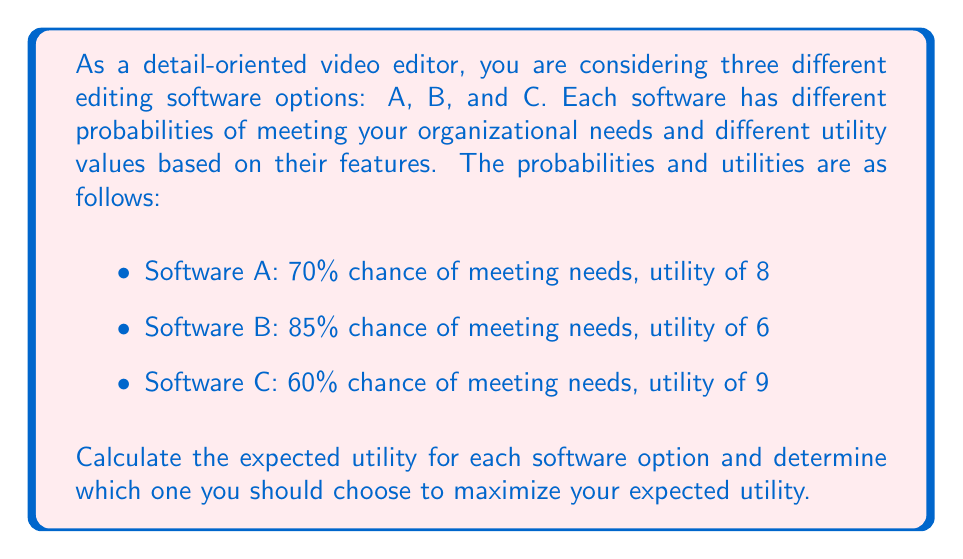Solve this math problem. To solve this problem, we need to calculate the expected utility for each software option using the formula:

$$ E(U) = P(S) \times U(S) + P(F) \times U(F) $$

Where:
$E(U)$ is the expected utility
$P(S)$ is the probability of success (meeting needs)
$U(S)$ is the utility if successful
$P(F)$ is the probability of failure (not meeting needs)
$U(F)$ is the utility if failed

We assume that the utility of failure is 0 for all options.

For Software A:
$$ E(U_A) = 0.70 \times 8 + 0.30 \times 0 = 5.60 $$

For Software B:
$$ E(U_B) = 0.85 \times 6 + 0.15 \times 0 = 5.10 $$

For Software C:
$$ E(U_C) = 0.60 \times 9 + 0.40 \times 0 = 5.40 $$

Comparing the expected utilities:
$$ E(U_A) = 5.60 > E(U_C) = 5.40 > E(U_B) = 5.10 $$

Therefore, Software A has the highest expected utility.
Answer: Software A has the highest expected utility of 5.60 and should be chosen to maximize expected utility. 